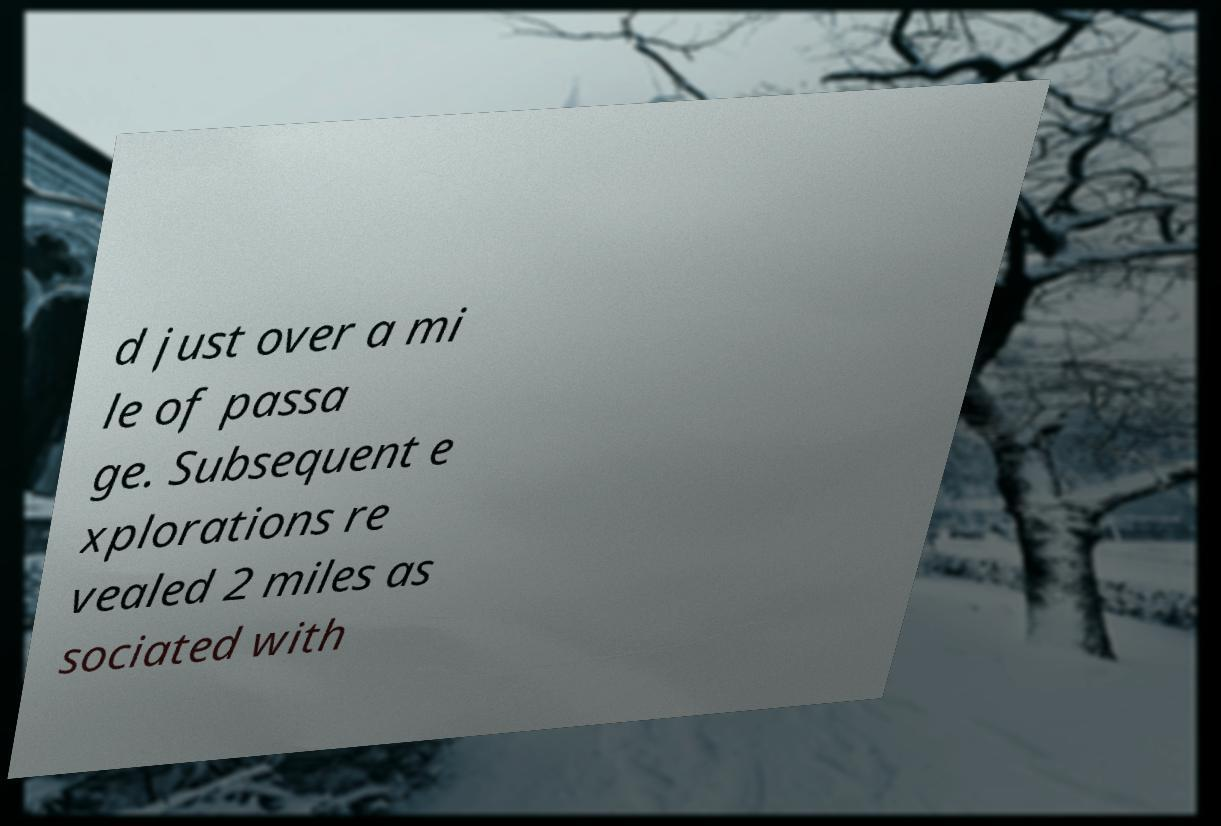What messages or text are displayed in this image? I need them in a readable, typed format. d just over a mi le of passa ge. Subsequent e xplorations re vealed 2 miles as sociated with 